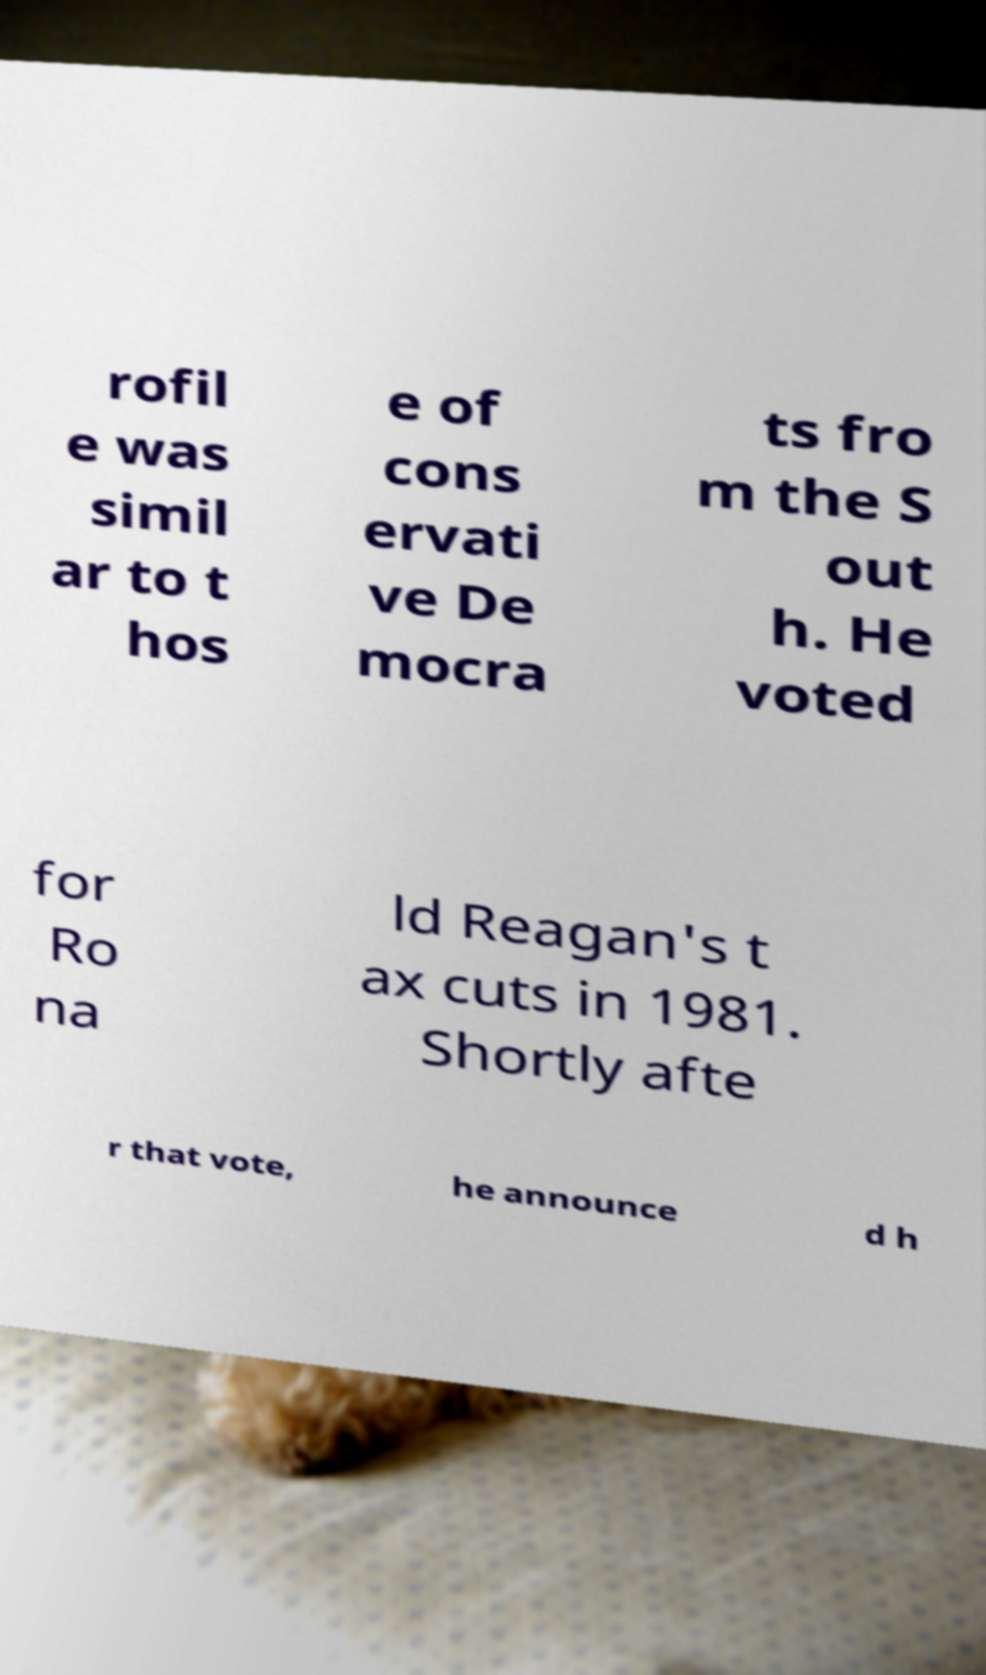Can you accurately transcribe the text from the provided image for me? rofil e was simil ar to t hos e of cons ervati ve De mocra ts fro m the S out h. He voted for Ro na ld Reagan's t ax cuts in 1981. Shortly afte r that vote, he announce d h 